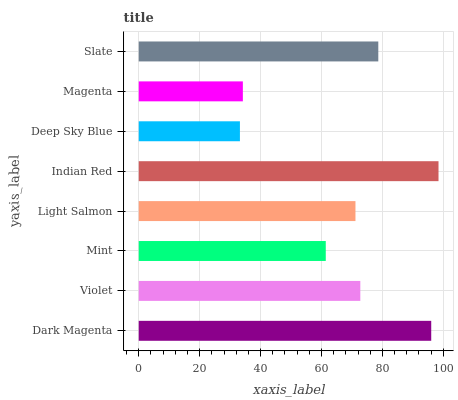Is Deep Sky Blue the minimum?
Answer yes or no. Yes. Is Indian Red the maximum?
Answer yes or no. Yes. Is Violet the minimum?
Answer yes or no. No. Is Violet the maximum?
Answer yes or no. No. Is Dark Magenta greater than Violet?
Answer yes or no. Yes. Is Violet less than Dark Magenta?
Answer yes or no. Yes. Is Violet greater than Dark Magenta?
Answer yes or no. No. Is Dark Magenta less than Violet?
Answer yes or no. No. Is Violet the high median?
Answer yes or no. Yes. Is Light Salmon the low median?
Answer yes or no. Yes. Is Light Salmon the high median?
Answer yes or no. No. Is Mint the low median?
Answer yes or no. No. 